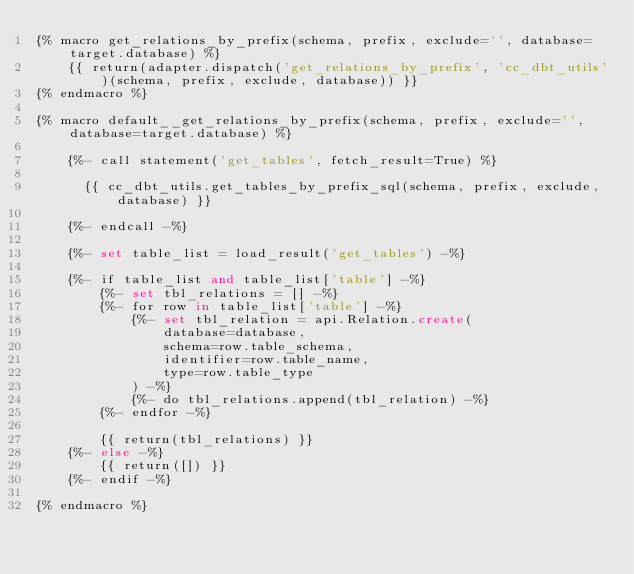Convert code to text. <code><loc_0><loc_0><loc_500><loc_500><_SQL_>{% macro get_relations_by_prefix(schema, prefix, exclude='', database=target.database) %}
    {{ return(adapter.dispatch('get_relations_by_prefix', 'cc_dbt_utils')(schema, prefix, exclude, database)) }}
{% endmacro %}

{% macro default__get_relations_by_prefix(schema, prefix, exclude='', database=target.database) %}

    {%- call statement('get_tables', fetch_result=True) %}

      {{ cc_dbt_utils.get_tables_by_prefix_sql(schema, prefix, exclude, database) }}

    {%- endcall -%}

    {%- set table_list = load_result('get_tables') -%}

    {%- if table_list and table_list['table'] -%}
        {%- set tbl_relations = [] -%}
        {%- for row in table_list['table'] -%}
            {%- set tbl_relation = api.Relation.create(
                database=database,
                schema=row.table_schema,
                identifier=row.table_name,
                type=row.table_type
            ) -%}
            {%- do tbl_relations.append(tbl_relation) -%}
        {%- endfor -%}

        {{ return(tbl_relations) }}
    {%- else -%}
        {{ return([]) }}
    {%- endif -%}

{% endmacro %}
</code> 